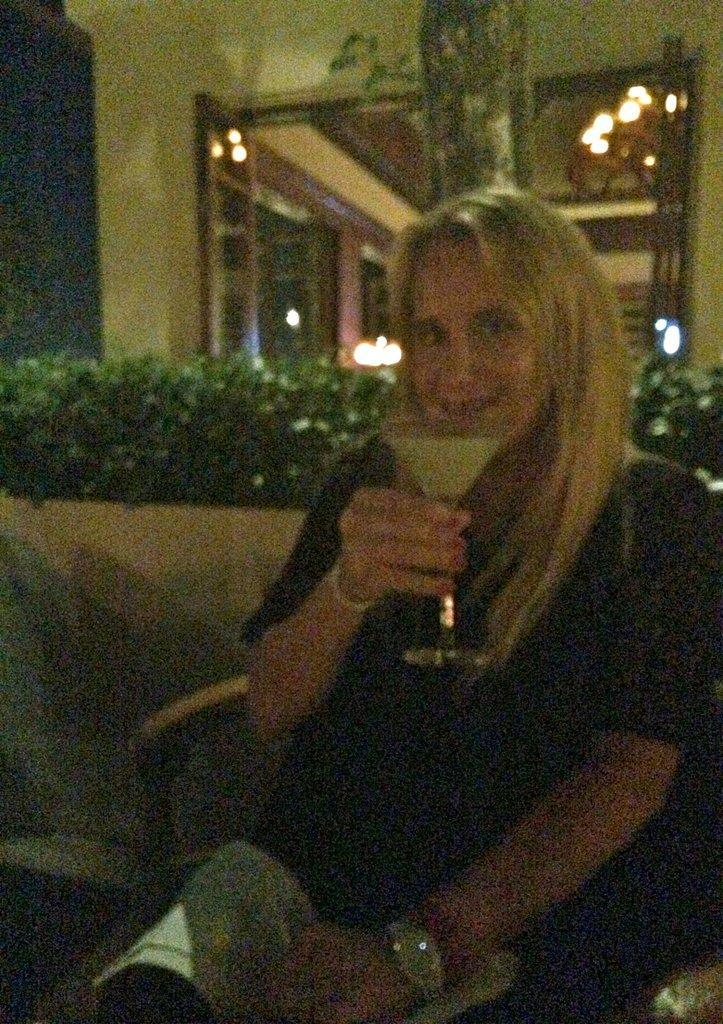How would you summarize this image in a sentence or two? In the center of the image, we can see a lady sitting on the chair and holding a paper and a glass with drink. In the background, there are lights and we can see planets and a tree trunk and there is a wall. 